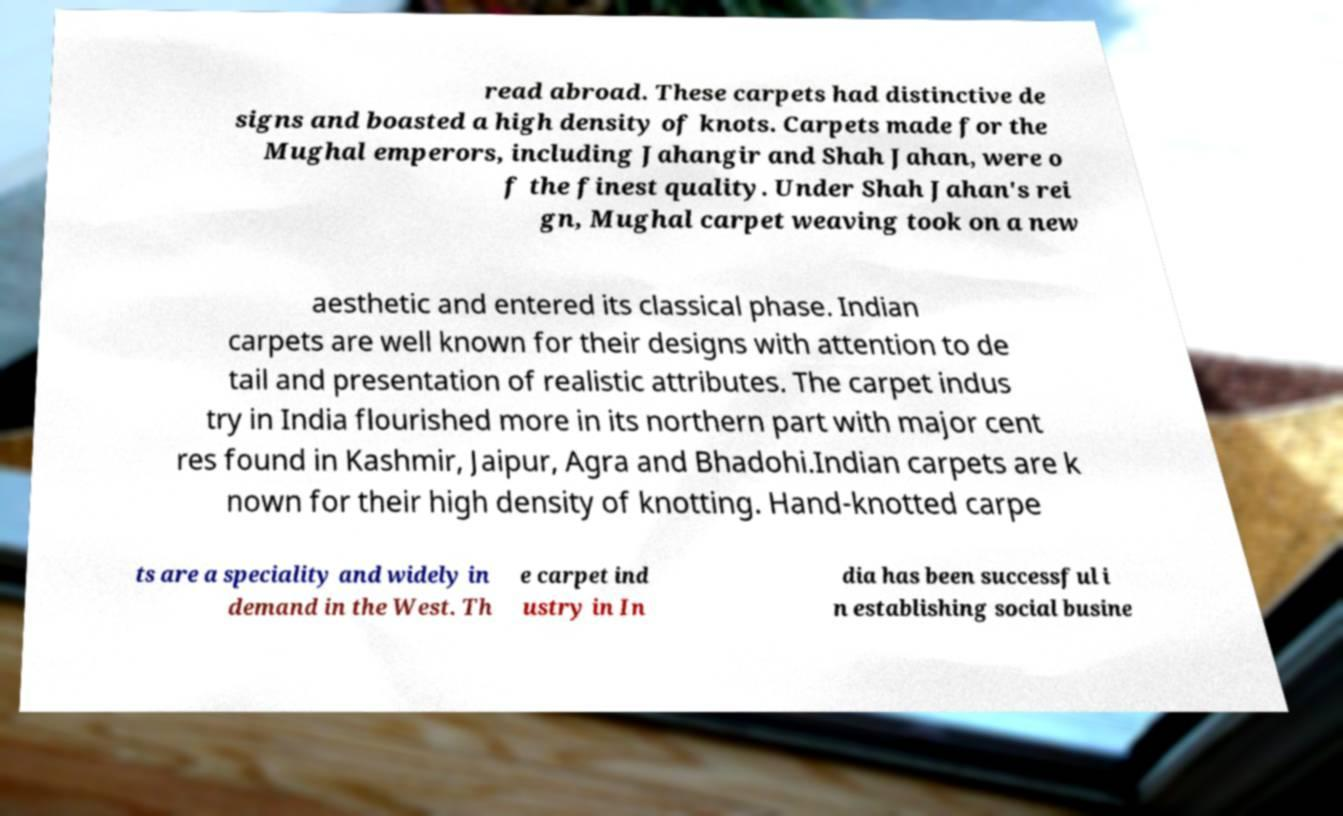What messages or text are displayed in this image? I need them in a readable, typed format. read abroad. These carpets had distinctive de signs and boasted a high density of knots. Carpets made for the Mughal emperors, including Jahangir and Shah Jahan, were o f the finest quality. Under Shah Jahan's rei gn, Mughal carpet weaving took on a new aesthetic and entered its classical phase. Indian carpets are well known for their designs with attention to de tail and presentation of realistic attributes. The carpet indus try in India flourished more in its northern part with major cent res found in Kashmir, Jaipur, Agra and Bhadohi.Indian carpets are k nown for their high density of knotting. Hand-knotted carpe ts are a speciality and widely in demand in the West. Th e carpet ind ustry in In dia has been successful i n establishing social busine 